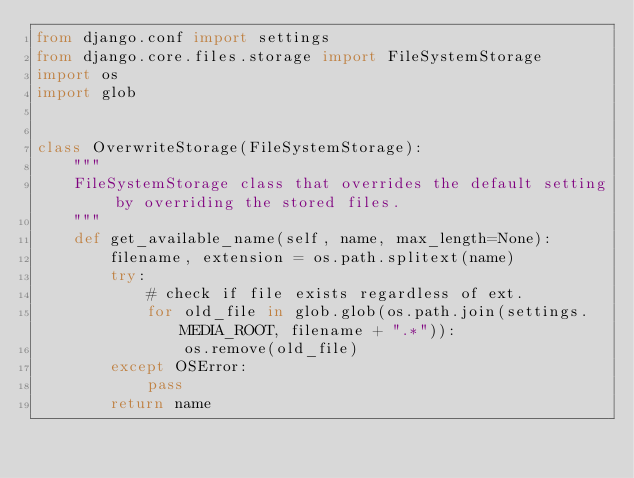<code> <loc_0><loc_0><loc_500><loc_500><_Python_>from django.conf import settings
from django.core.files.storage import FileSystemStorage
import os
import glob


class OverwriteStorage(FileSystemStorage):
    """
    FileSystemStorage class that overrides the default setting by overriding the stored files.
    """
    def get_available_name(self, name, max_length=None):
        filename, extension = os.path.splitext(name)
        try:
            # check if file exists regardless of ext.
            for old_file in glob.glob(os.path.join(settings.MEDIA_ROOT, filename + ".*")):
                os.remove(old_file)
        except OSError:
            pass
        return name
</code> 